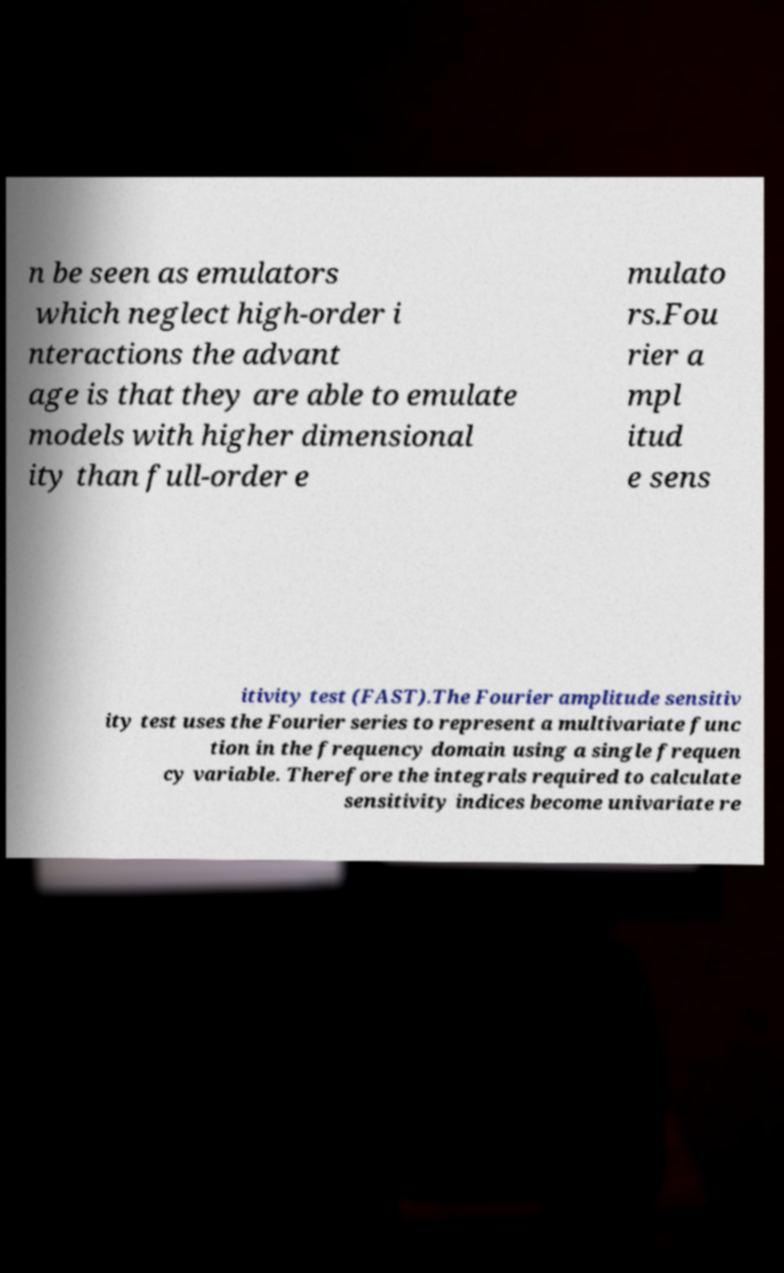Can you read and provide the text displayed in the image?This photo seems to have some interesting text. Can you extract and type it out for me? n be seen as emulators which neglect high-order i nteractions the advant age is that they are able to emulate models with higher dimensional ity than full-order e mulato rs.Fou rier a mpl itud e sens itivity test (FAST).The Fourier amplitude sensitiv ity test uses the Fourier series to represent a multivariate func tion in the frequency domain using a single frequen cy variable. Therefore the integrals required to calculate sensitivity indices become univariate re 